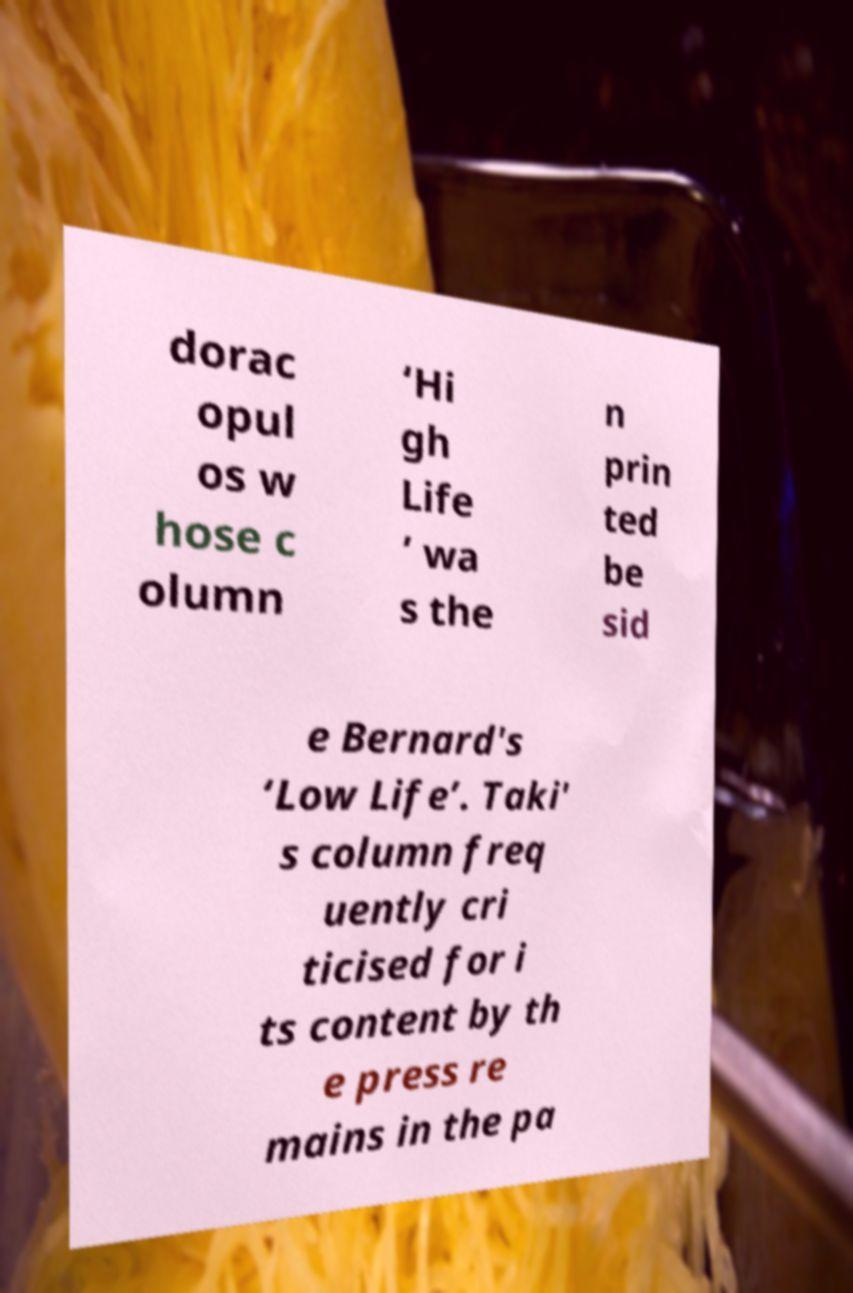Can you accurately transcribe the text from the provided image for me? dorac opul os w hose c olumn ‘Hi gh Life ’ wa s the n prin ted be sid e Bernard's ‘Low Life’. Taki' s column freq uently cri ticised for i ts content by th e press re mains in the pa 